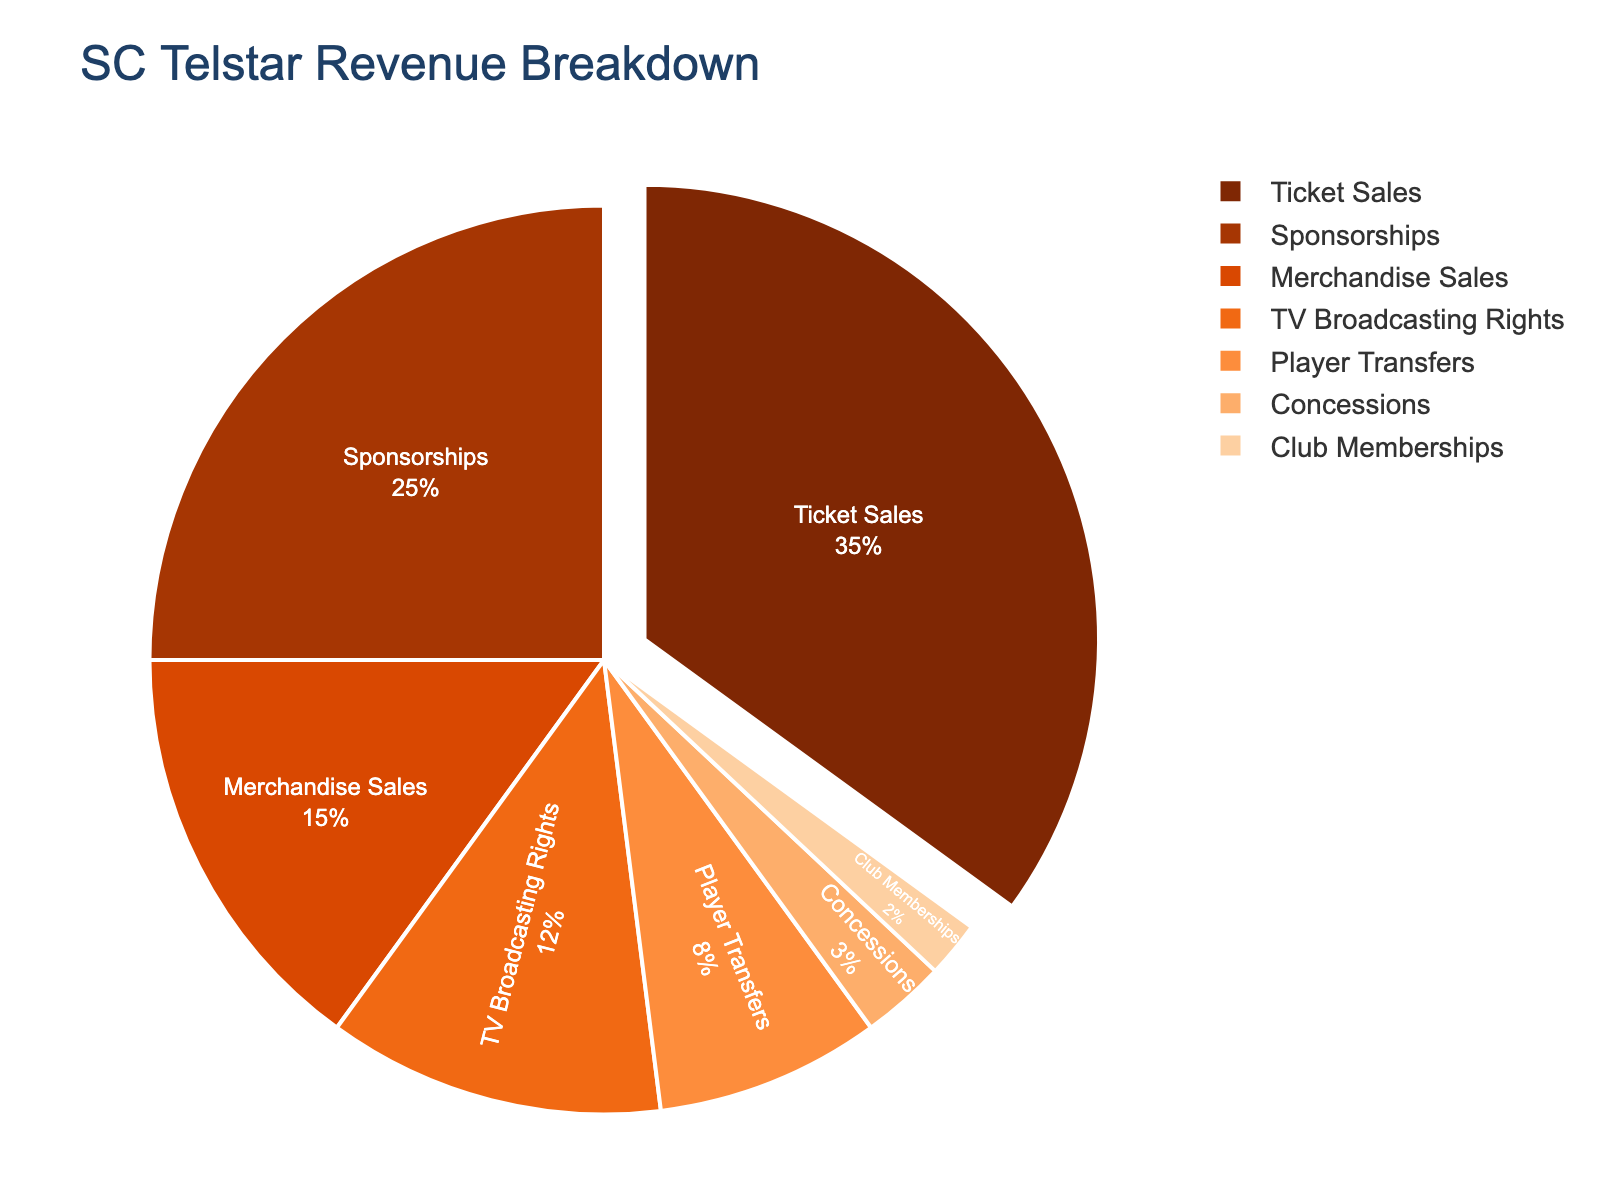What's the title of the pie chart? The title of the pie chart is usually displayed prominently at the top. In this case, it says "SC Telstar Revenue Breakdown".
Answer: SC Telstar Revenue Breakdown What revenue source contributes the most to SC Telstar's total revenue? The pie chart indicates the largest segment by size and percentage, which is usually highlighted. The segment for "Ticket Sales" is the largest, contributing 35% to the total revenue.
Answer: Ticket Sales Which two revenue sources contribute the least to SC Telstar's revenue? To find the two smallest segments, look for the segments with the smallest percentages. "Concessions" at 3% and "Club Memberships" at 2% are the smallest.
Answer: Concessions and Club Memberships What percentage of revenue does SC Telstar generate through merchandise sales? The pie chart has a segment labeled "Merchandise Sales" which represents a certain percentage of the entire pie. This segment shows 15%.
Answer: 15% How much more does SC Telstar earn from ticket sales compared to player transfers? Subtract the percentage for Player Transfers from Ticket Sales. Ticket Sales contribute 35%, and Player Transfers contribute 8%, so the difference is 35% - 8%.
Answer: 27% What is the sum of the revenue percentages from Sponsorships and TV Broadcasting Rights? Add the percentages from Sponsorships and TV Broadcasting Rights together. Sponsorships contribute 25%, and TV Broadcasting Rights contribute 12%, so the sum is 25% + 12%.
Answer: 37% Which is greater: the combined revenue percentage of Merchandise Sales and Concessions or the revenue percentage from Sponsorships? Add the percentages of Merchandise Sales and Concessions and then compare it to the percentage from Sponsorships. Merchandise Sales (15%) + Concessions (3%) = 18%, which is less than Sponsorships (25%).
Answer: Sponsorships What percentage of SC Telstar's revenue is not from ticket sales or sponsorships? Subtract the sum of the percentages of Ticket Sales and Sponsorships from 100%. Ticket Sales (35%) + Sponsorships (25%) = 60%, so 100% - 60% = 40%.
Answer: 40% How many categories contribute more than 10% to SC Telstar’s revenue? Count the segments in the pie chart that have percentages greater than 10%. Ticket Sales (35%), Sponsorships (25%), Merchandise Sales (15%), and TV Broadcasting Rights (12%) all contribute more than 10%. This gives a total of 4 categories.
Answer: 4 What percentage of revenue is derived from sources other than Ticket Sales, Sponsorships, Merchandise Sales, and TV Broadcasting Rights? Calculate the sum of the given percentages and subtract from 100%. The sum is Ticket Sales (35%) + Sponsorships (25%) + Merchandise Sales (15%) + TV Broadcasting Rights (12%) = 87%. So, 100% - 87% = 13%.
Answer: 13% 